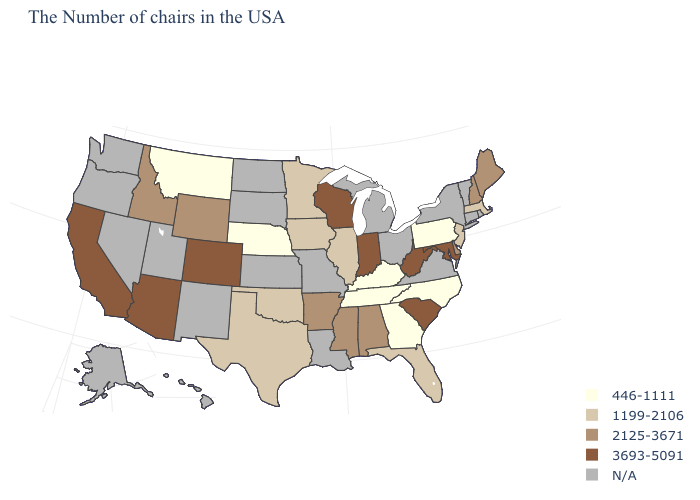Does Delaware have the highest value in the USA?
Short answer required. No. Name the states that have a value in the range 1199-2106?
Concise answer only. Massachusetts, New Jersey, Florida, Illinois, Minnesota, Iowa, Oklahoma, Texas. Name the states that have a value in the range N/A?
Quick response, please. Rhode Island, Vermont, Connecticut, New York, Virginia, Ohio, Michigan, Louisiana, Missouri, Kansas, South Dakota, North Dakota, New Mexico, Utah, Nevada, Washington, Oregon, Alaska, Hawaii. What is the value of Virginia?
Short answer required. N/A. Does the map have missing data?
Concise answer only. Yes. What is the lowest value in the USA?
Be succinct. 446-1111. What is the value of Washington?
Be succinct. N/A. Name the states that have a value in the range 2125-3671?
Give a very brief answer. Maine, New Hampshire, Delaware, Alabama, Mississippi, Arkansas, Wyoming, Idaho. Name the states that have a value in the range 1199-2106?
Short answer required. Massachusetts, New Jersey, Florida, Illinois, Minnesota, Iowa, Oklahoma, Texas. What is the value of Washington?
Short answer required. N/A. Which states hav the highest value in the West?
Write a very short answer. Colorado, Arizona, California. What is the value of Mississippi?
Write a very short answer. 2125-3671. Name the states that have a value in the range 3693-5091?
Keep it brief. Maryland, South Carolina, West Virginia, Indiana, Wisconsin, Colorado, Arizona, California. What is the value of South Carolina?
Keep it brief. 3693-5091. What is the value of Washington?
Answer briefly. N/A. 